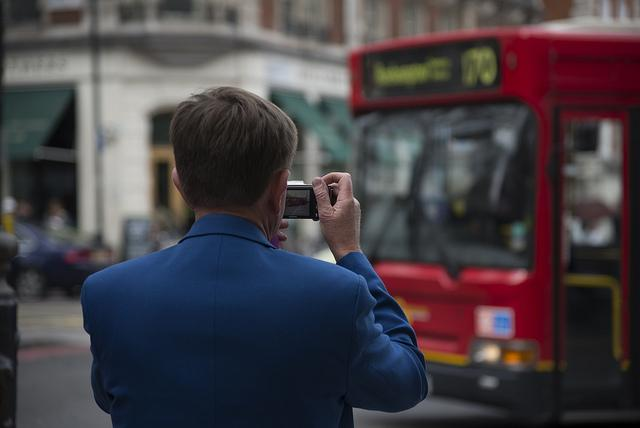What is the person in blue coat doing? taking pictures 